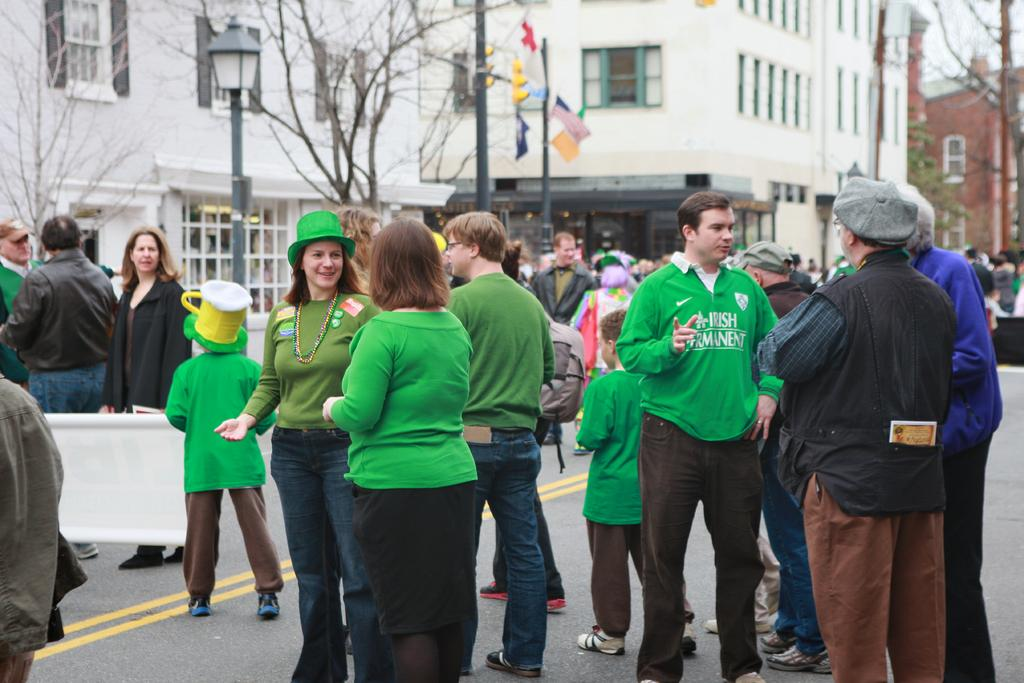What is the main subject in the foreground of the image? There is a crowd in the foreground of the image. Where is the crowd located? The crowd is on the road. What can be seen in the background of the image? There are buildings, windows, light poles, trees, and boards visible in the background. What time of day was the image taken? The image was taken during the day. What type of seed is being planted by the deer in the image? There are no deer or seeds present in the image; it features a crowd on the road with various elements in the background. 